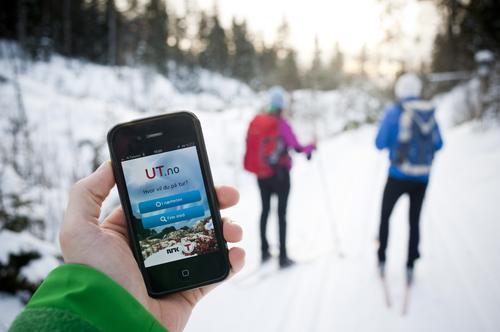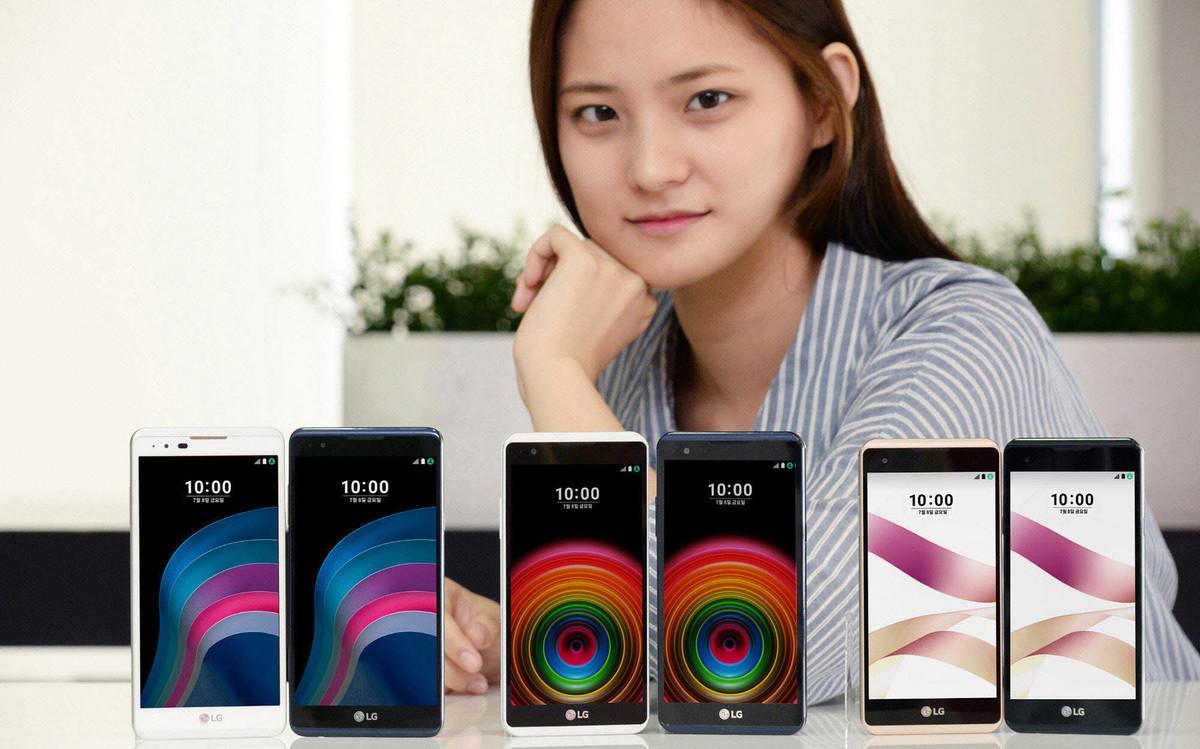The first image is the image on the left, the second image is the image on the right. Considering the images on both sides, is "The left image features two palms-up hands, each holding a screen-side up phone next to the other phone." valid? Answer yes or no. No. The first image is the image on the left, the second image is the image on the right. For the images displayed, is the sentence "The left and right image contains a total of four phones." factually correct? Answer yes or no. No. 